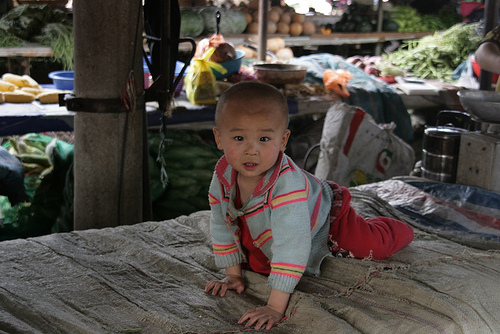<image>
Can you confirm if the coconut is behind the baby? Yes. From this viewpoint, the coconut is positioned behind the baby, with the baby partially or fully occluding the coconut. 